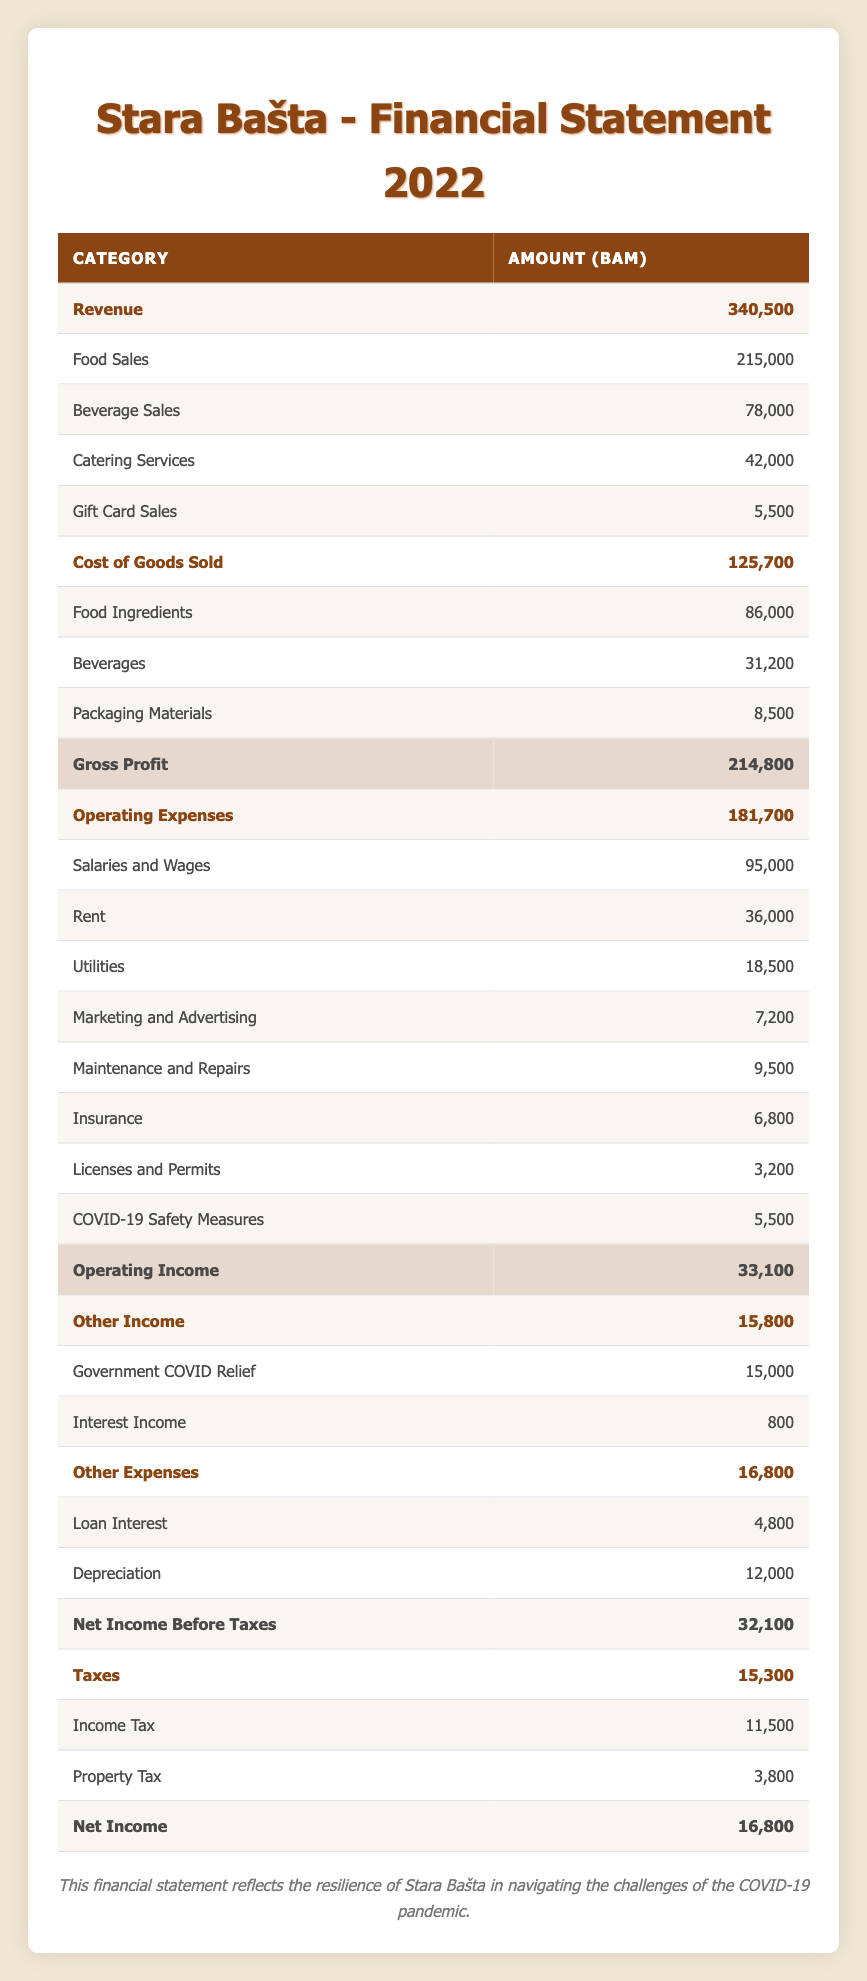What is the total revenue for Stara Bašta in 2022? The total revenue can be found in the table where "Revenue" is listed as 340,500. This value encompasses all the sales categories including food sales, beverage sales, catering services, and gift card sales.
Answer: 340,500 What was the gross profit in 2022? The gross profit can be calculated by subtracting the total cost of goods sold (125,700) from the total revenue (340,500). Therefore, gross profit = 340,500 - 125,700 = 214,800.
Answer: 214,800 Is the total operating expenses greater than the total other expenses? Total operating expenses are listed as 181,700, while total other expenses are 16,800. Since 181,700 is greater than 16,800, the statement is true.
Answer: Yes What is the net income before taxes for Stara Bašta? The net income before taxes can be found in the table, listed as 32,100. This number results from subtracting total other expenses (16,800) from the operating income (33,100).
Answer: 32,100 How much did Stara Bašta spend on COVID-19 safety measures compared to its total operating expenses? Total operating expenses are 181,700 and COVID-19 safety measures accounted for 5,500. To find the percentage, (5,500 / 181,700) * 100 gives approximately 3.03%. Therefore, they spent around 3.03% of their operating expenses on safety measures.
Answer: 3.03% What is the total tax amount paid by Stara Bašta? The total tax amount is a sum of income tax (11,500) and property tax (3,800). Thus, total taxes = 11,500 + 3,800 = 15,300.
Answer: 15,300 Is the income from government COVID relief greater than the income from interest? The income from government COVID relief is 15,000 and interest income is 800. Since 15,000 is greater than 800, the statement is true.
Answer: Yes What is the difference between total revenue and total operating expenses? Total revenue is 340,500 and total operating expenses are 181,700. The difference can be calculated by subtracting operating expenses from revenue: 340,500 - 181,700 = 158,800.
Answer: 158,800 What percentage of the total revenue is gained from food sales? Food sales are 215,000, and total revenue is 340,500. The percentage is calculated as (215,000 / 340,500) * 100, which is approximately 63.1%.
Answer: 63.1% 